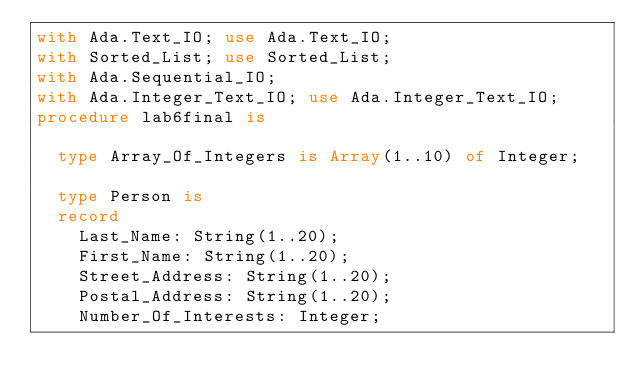<code> <loc_0><loc_0><loc_500><loc_500><_Ada_>with Ada.Text_IO; use Ada.Text_IO;
with Sorted_List; use Sorted_List;
with Ada.Sequential_IO;
with Ada.Integer_Text_IO; use Ada.Integer_Text_IO;
procedure lab6final is

	type Array_Of_Integers is Array(1..10) of Integer;

	type Person is
	record
		Last_Name: String(1..20);
		First_Name: String(1..20);
		Street_Address: String(1..20);
		Postal_Address: String(1..20);
		Number_Of_Interests: Integer;</code> 